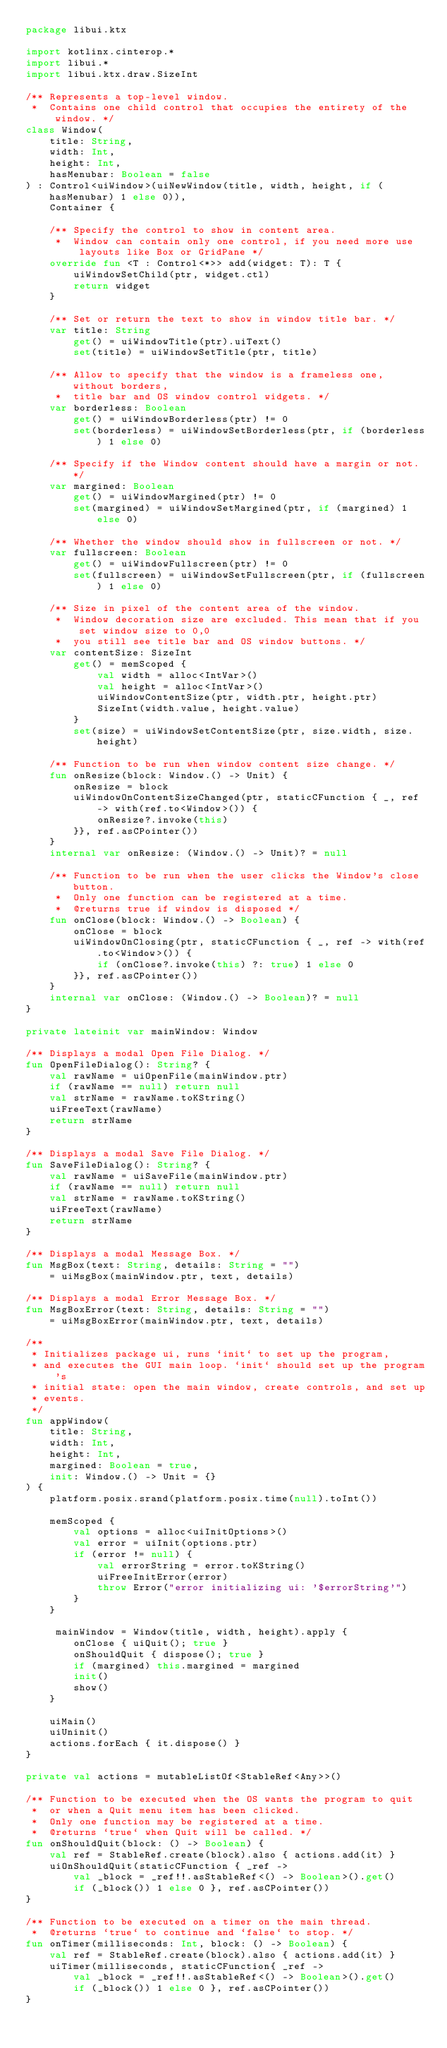Convert code to text. <code><loc_0><loc_0><loc_500><loc_500><_Kotlin_>package libui.ktx

import kotlinx.cinterop.*
import libui.*
import libui.ktx.draw.SizeInt

/** Represents a top-level window.
 *  Contains one child control that occupies the entirety of the window. */
class Window(
    title: String,
    width: Int,
    height: Int,
    hasMenubar: Boolean = false
) : Control<uiWindow>(uiNewWindow(title, width, height, if (hasMenubar) 1 else 0)),
    Container {

    /** Specify the control to show in content area.
     *  Window can contain only one control, if you need more use layouts like Box or GridPane */
    override fun <T : Control<*>> add(widget: T): T {
        uiWindowSetChild(ptr, widget.ctl)
        return widget
    }

    /** Set or return the text to show in window title bar. */
    var title: String
        get() = uiWindowTitle(ptr).uiText()
        set(title) = uiWindowSetTitle(ptr, title)

    /** Allow to specify that the window is a frameless one, without borders,
     *  title bar and OS window control widgets. */
    var borderless: Boolean
        get() = uiWindowBorderless(ptr) != 0
        set(borderless) = uiWindowSetBorderless(ptr, if (borderless) 1 else 0)

    /** Specify if the Window content should have a margin or not. */
    var margined: Boolean
        get() = uiWindowMargined(ptr) != 0
        set(margined) = uiWindowSetMargined(ptr, if (margined) 1 else 0)

    /** Whether the window should show in fullscreen or not. */
    var fullscreen: Boolean
        get() = uiWindowFullscreen(ptr) != 0
        set(fullscreen) = uiWindowSetFullscreen(ptr, if (fullscreen) 1 else 0)

    /** Size in pixel of the content area of the window.
     *  Window decoration size are excluded. This mean that if you set window size to 0,0
     *  you still see title bar and OS window buttons. */
    var contentSize: SizeInt
        get() = memScoped {
            val width = alloc<IntVar>()
            val height = alloc<IntVar>()
            uiWindowContentSize(ptr, width.ptr, height.ptr)
            SizeInt(width.value, height.value)
        }
        set(size) = uiWindowSetContentSize(ptr, size.width, size.height)

    /** Function to be run when window content size change. */
    fun onResize(block: Window.() -> Unit) {
        onResize = block
        uiWindowOnContentSizeChanged(ptr, staticCFunction { _, ref -> with(ref.to<Window>()) {
            onResize?.invoke(this)
        }}, ref.asCPointer())
    }
    internal var onResize: (Window.() -> Unit)? = null

    /** Function to be run when the user clicks the Window's close button.
     *  Only one function can be registered at a time.
     *  @returns true if window is disposed */
    fun onClose(block: Window.() -> Boolean) {
        onClose = block
        uiWindowOnClosing(ptr, staticCFunction { _, ref -> with(ref.to<Window>()) {
            if (onClose?.invoke(this) ?: true) 1 else 0
        }}, ref.asCPointer())
    }
    internal var onClose: (Window.() -> Boolean)? = null
}

private lateinit var mainWindow: Window

/** Displays a modal Open File Dialog. */
fun OpenFileDialog(): String? {
    val rawName = uiOpenFile(mainWindow.ptr)
    if (rawName == null) return null
    val strName = rawName.toKString()
    uiFreeText(rawName)
    return strName
}

/** Displays a modal Save File Dialog. */
fun SaveFileDialog(): String? {
    val rawName = uiSaveFile(mainWindow.ptr)
    if (rawName == null) return null
    val strName = rawName.toKString()
    uiFreeText(rawName)
    return strName
}

/** Displays a modal Message Box. */
fun MsgBox(text: String, details: String = "")
    = uiMsgBox(mainWindow.ptr, text, details)

/** Displays a modal Error Message Box. */
fun MsgBoxError(text: String, details: String = "")
    = uiMsgBoxError(mainWindow.ptr, text, details)

/**
 * Initializes package ui, runs `init` to set up the program,
 * and executes the GUI main loop. `init` should set up the program's
 * initial state: open the main window, create controls, and set up
 * events.
 */
fun appWindow(
    title: String,
    width: Int,
    height: Int,
    margined: Boolean = true,
    init: Window.() -> Unit = {}
) {
    platform.posix.srand(platform.posix.time(null).toInt())

    memScoped {
        val options = alloc<uiInitOptions>()
        val error = uiInit(options.ptr)
        if (error != null) {
            val errorString = error.toKString()
            uiFreeInitError(error)
            throw Error("error initializing ui: '$errorString'")
        }
    }

     mainWindow = Window(title, width, height).apply {
        onClose { uiQuit(); true }
        onShouldQuit { dispose(); true }
        if (margined) this.margined = margined
        init()
        show()
    }

    uiMain()
    uiUninit()
    actions.forEach { it.dispose() }
}

private val actions = mutableListOf<StableRef<Any>>()

/** Function to be executed when the OS wants the program to quit
 *  or when a Quit menu item has been clicked.
 *  Only one function may be registered at a time.
 *  @returns `true` when Quit will be called. */
fun onShouldQuit(block: () -> Boolean) {
    val ref = StableRef.create(block).also { actions.add(it) }
    uiOnShouldQuit(staticCFunction { _ref ->
        val _block = _ref!!.asStableRef<() -> Boolean>().get()
        if (_block()) 1 else 0 }, ref.asCPointer())
}

/** Function to be executed on a timer on the main thread.
 *  @returns `true` to continue and `false` to stop. */
fun onTimer(milliseconds: Int, block: () -> Boolean) {
    val ref = StableRef.create(block).also { actions.add(it) }
    uiTimer(milliseconds, staticCFunction{ _ref ->
        val _block = _ref!!.asStableRef<() -> Boolean>().get()
        if (_block()) 1 else 0 }, ref.asCPointer())
}
</code> 